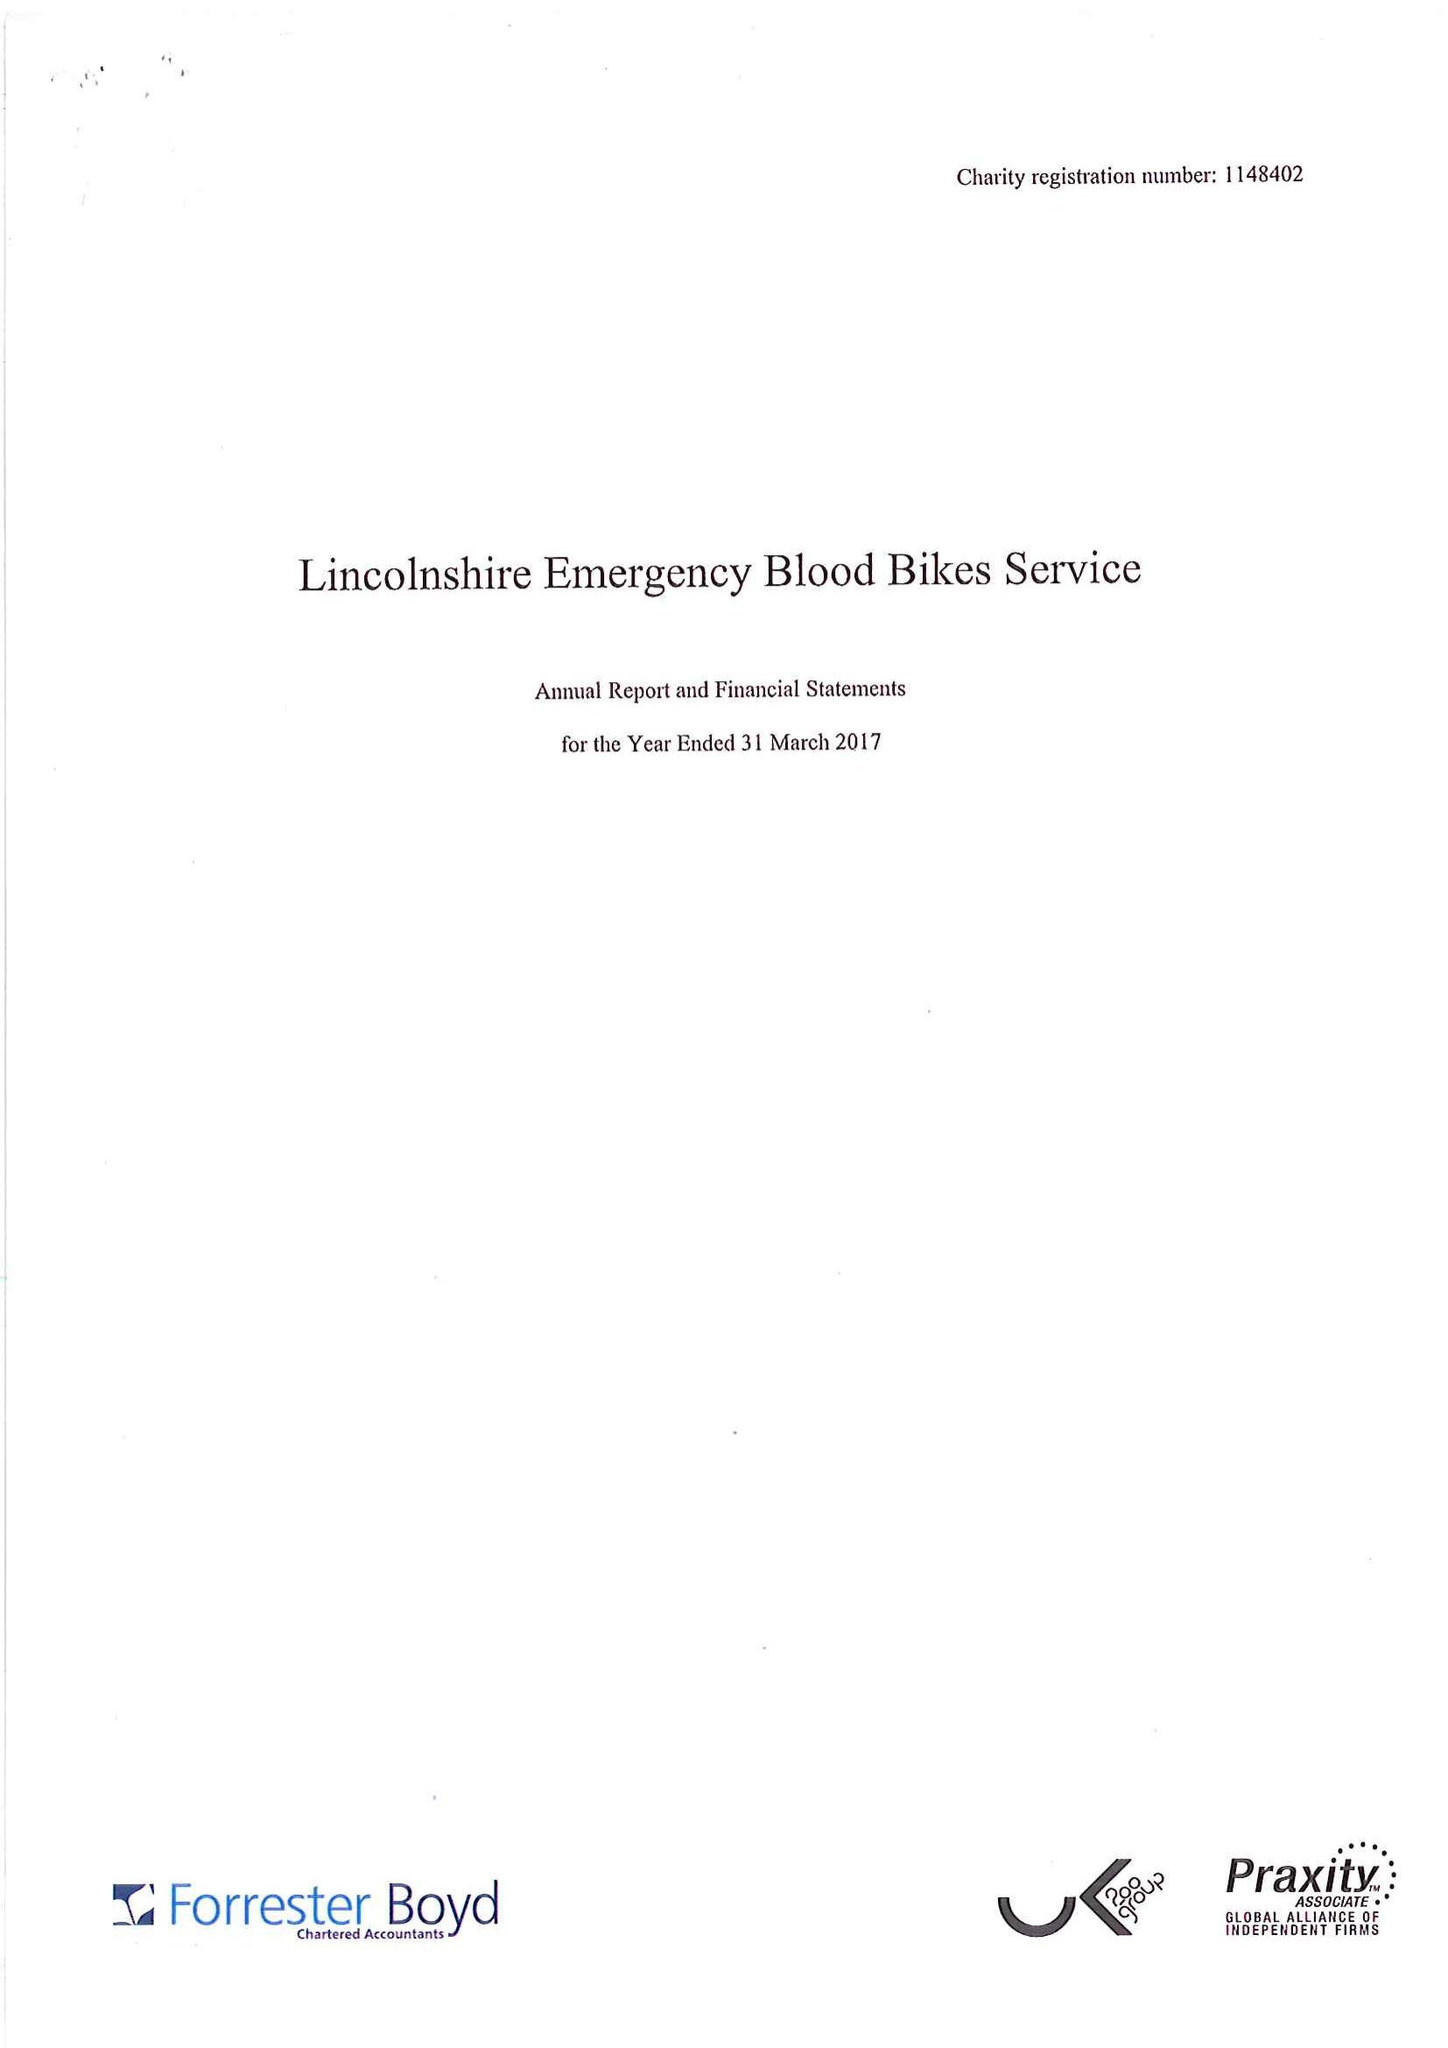What is the value for the address__street_line?
Answer the question using a single word or phrase. LEGBOURNE ROAD 